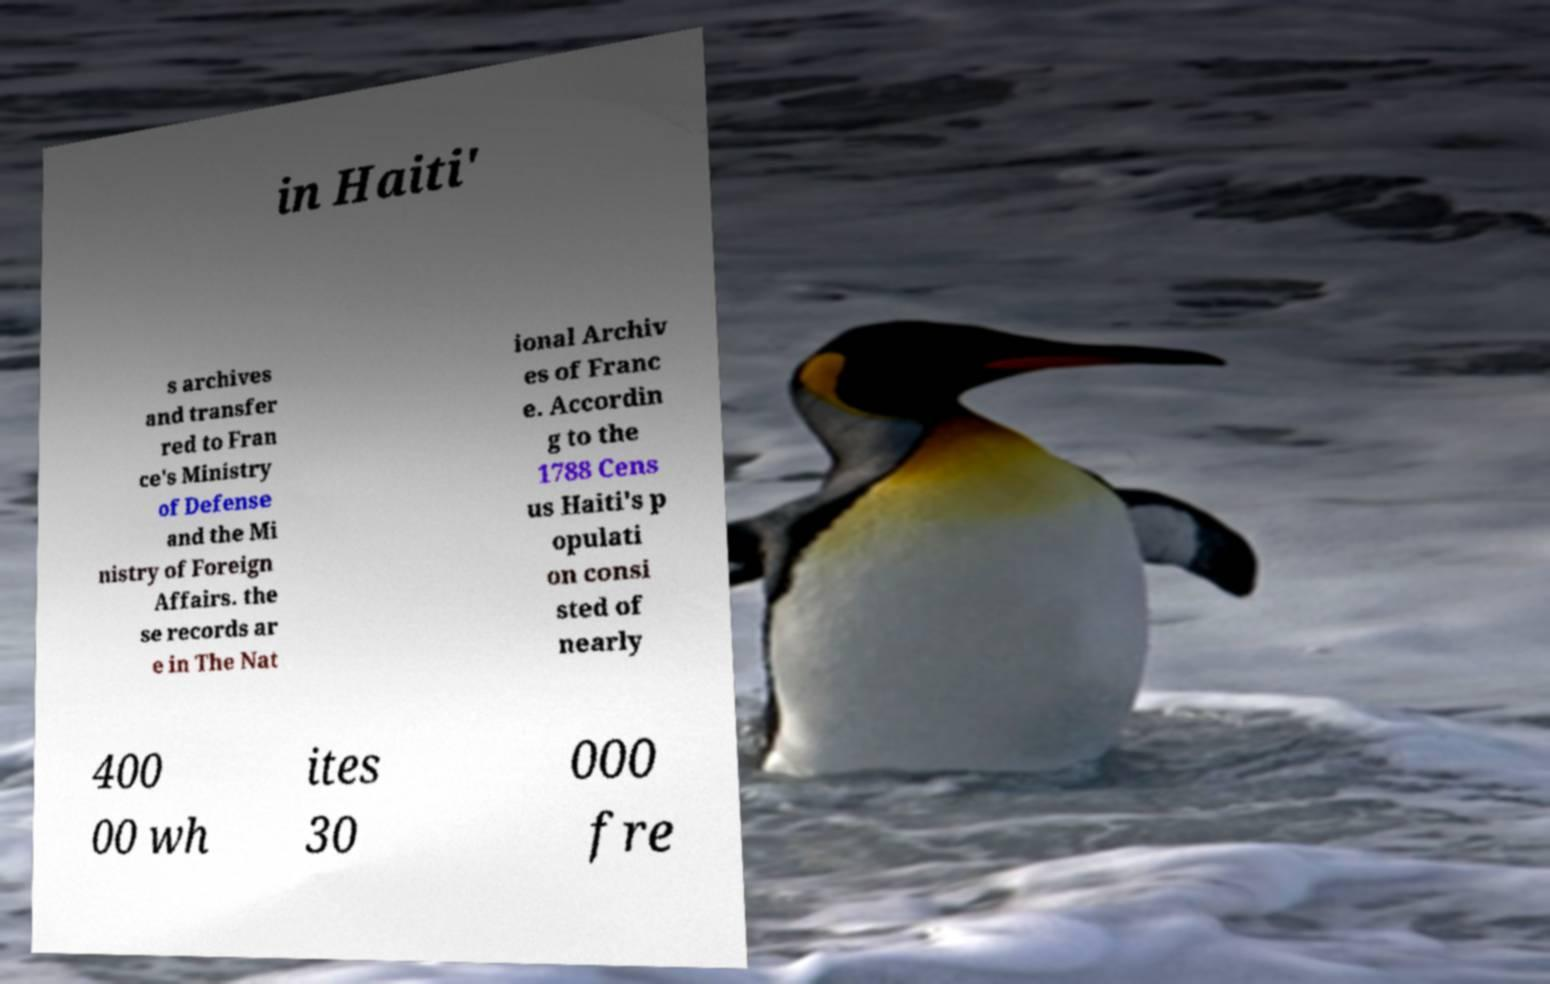Could you assist in decoding the text presented in this image and type it out clearly? in Haiti' s archives and transfer red to Fran ce's Ministry of Defense and the Mi nistry of Foreign Affairs. the se records ar e in The Nat ional Archiv es of Franc e. Accordin g to the 1788 Cens us Haiti's p opulati on consi sted of nearly 400 00 wh ites 30 000 fre 